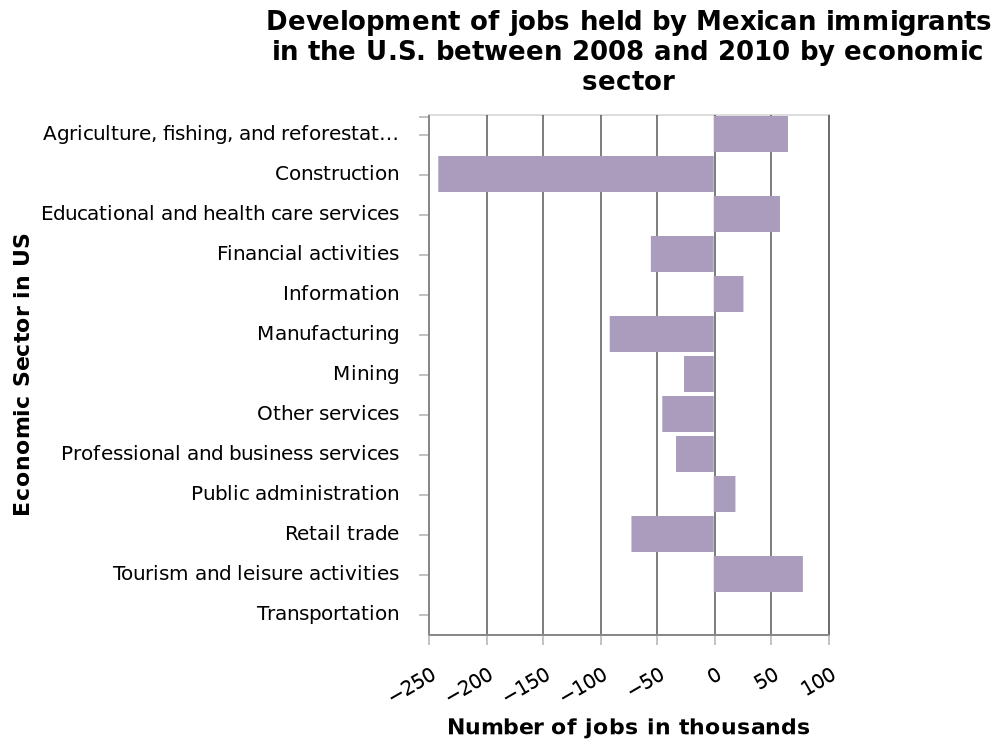<image>
Offer a thorough analysis of the image. The largest increase is in the Tourism and leisure activities sector. The largest decrease is in the construction sector. 